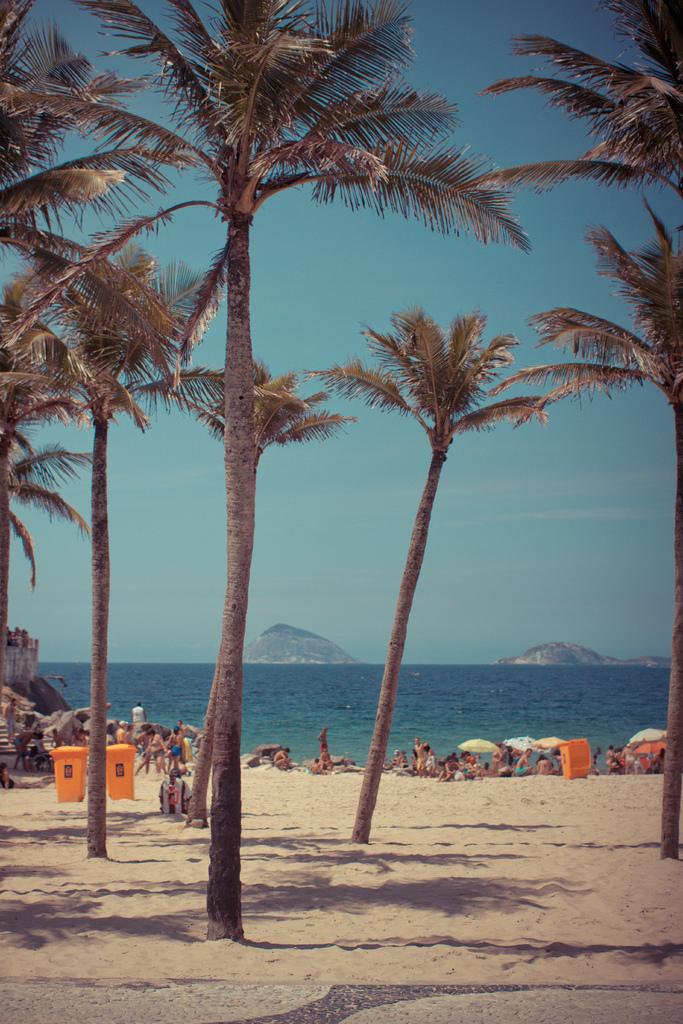What type of location is depicted in the image? The image contains a beach. Are there any people present at the beach? Yes, there are persons on the beach. What other natural elements can be seen on the beach? There are trees on the beach. Where can trash be disposed of on the beach? There are trash bins in the bottom left of the image. What can be seen in the background of the image? The sky is visible in the background of the image. What color is the silver wristband worn by the person on the beach? There is no silver wristband visible on any person in the image. 